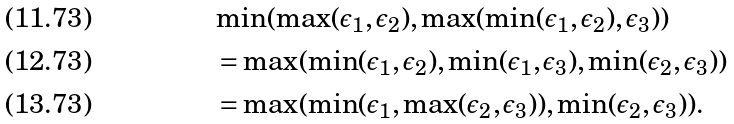Convert formula to latex. <formula><loc_0><loc_0><loc_500><loc_500>& \min ( \max ( \epsilon _ { 1 } , \epsilon _ { 2 } ) , \max ( \min ( \epsilon _ { 1 } , \epsilon _ { 2 } ) , \epsilon _ { 3 } ) ) & \\ & = \max ( \min ( \epsilon _ { 1 } , \epsilon _ { 2 } ) , \min ( \epsilon _ { 1 } , \epsilon _ { 3 } ) , \min ( \epsilon _ { 2 } , \epsilon _ { 3 } ) ) & \\ & = \max ( \min ( \epsilon _ { 1 } , \max ( \epsilon _ { 2 } , \epsilon _ { 3 } ) ) , \min ( \epsilon _ { 2 } , \epsilon _ { 3 } ) ) .</formula> 